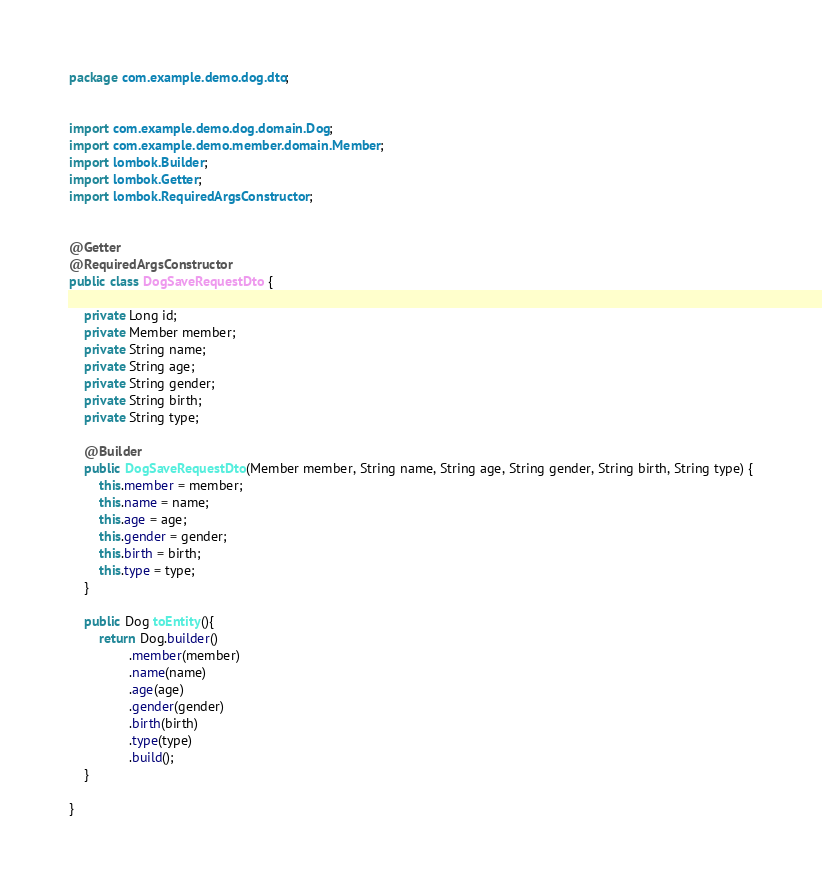Convert code to text. <code><loc_0><loc_0><loc_500><loc_500><_Java_>package com.example.demo.dog.dto;


import com.example.demo.dog.domain.Dog;
import com.example.demo.member.domain.Member;
import lombok.Builder;
import lombok.Getter;
import lombok.RequiredArgsConstructor;


@Getter
@RequiredArgsConstructor
public class DogSaveRequestDto {

    private Long id;
    private Member member;
    private String name;
    private String age;
    private String gender;
    private String birth;
    private String type;

    @Builder
    public DogSaveRequestDto(Member member, String name, String age, String gender, String birth, String type) {
        this.member = member;
        this.name = name;
        this.age = age;
        this.gender = gender;
        this.birth = birth;
        this.type = type;
    }

    public Dog toEntity(){
        return Dog.builder()
                .member(member)
                .name(name)
                .age(age)
                .gender(gender)
                .birth(birth)
                .type(type)
                .build();
    }

}
</code> 